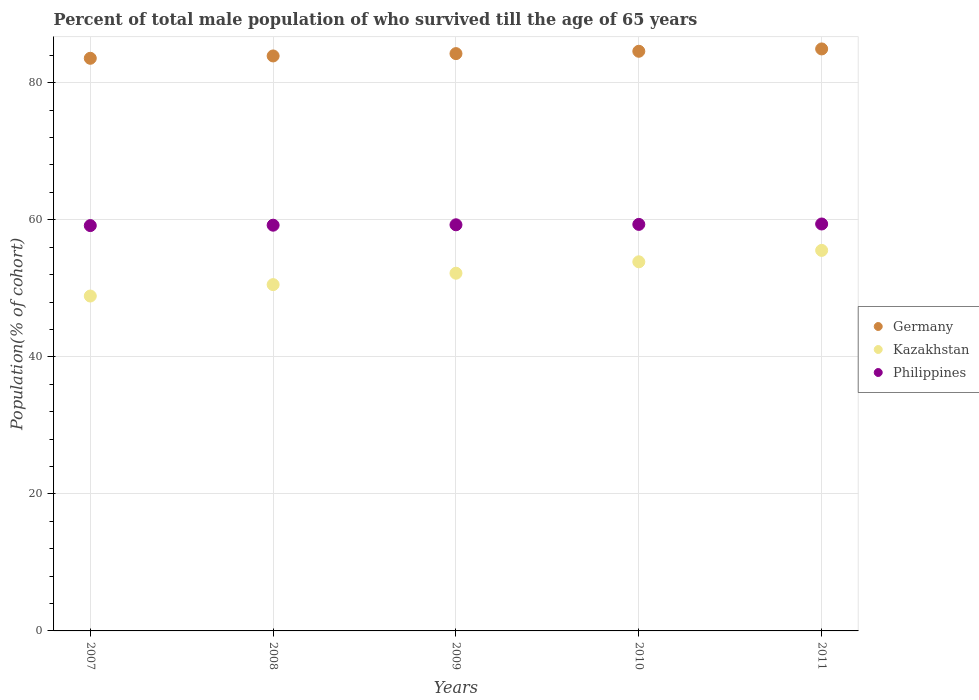What is the percentage of total male population who survived till the age of 65 years in Germany in 2010?
Keep it short and to the point. 84.59. Across all years, what is the maximum percentage of total male population who survived till the age of 65 years in Kazakhstan?
Keep it short and to the point. 55.53. Across all years, what is the minimum percentage of total male population who survived till the age of 65 years in Kazakhstan?
Provide a succinct answer. 48.87. In which year was the percentage of total male population who survived till the age of 65 years in Germany maximum?
Make the answer very short. 2011. In which year was the percentage of total male population who survived till the age of 65 years in Philippines minimum?
Make the answer very short. 2007. What is the total percentage of total male population who survived till the age of 65 years in Kazakhstan in the graph?
Your answer should be compact. 261.01. What is the difference between the percentage of total male population who survived till the age of 65 years in Germany in 2010 and that in 2011?
Ensure brevity in your answer.  -0.34. What is the difference between the percentage of total male population who survived till the age of 65 years in Kazakhstan in 2007 and the percentage of total male population who survived till the age of 65 years in Germany in 2010?
Your answer should be very brief. -35.72. What is the average percentage of total male population who survived till the age of 65 years in Germany per year?
Offer a very short reply. 84.25. In the year 2008, what is the difference between the percentage of total male population who survived till the age of 65 years in Kazakhstan and percentage of total male population who survived till the age of 65 years in Germany?
Provide a succinct answer. -33.37. What is the ratio of the percentage of total male population who survived till the age of 65 years in Germany in 2007 to that in 2008?
Your response must be concise. 1. Is the percentage of total male population who survived till the age of 65 years in Germany in 2008 less than that in 2010?
Your response must be concise. Yes. Is the difference between the percentage of total male population who survived till the age of 65 years in Kazakhstan in 2008 and 2011 greater than the difference between the percentage of total male population who survived till the age of 65 years in Germany in 2008 and 2011?
Provide a succinct answer. No. What is the difference between the highest and the second highest percentage of total male population who survived till the age of 65 years in Kazakhstan?
Offer a terse response. 1.66. What is the difference between the highest and the lowest percentage of total male population who survived till the age of 65 years in Kazakhstan?
Make the answer very short. 6.66. In how many years, is the percentage of total male population who survived till the age of 65 years in Germany greater than the average percentage of total male population who survived till the age of 65 years in Germany taken over all years?
Offer a terse response. 3. Is it the case that in every year, the sum of the percentage of total male population who survived till the age of 65 years in Kazakhstan and percentage of total male population who survived till the age of 65 years in Philippines  is greater than the percentage of total male population who survived till the age of 65 years in Germany?
Keep it short and to the point. Yes. Does the percentage of total male population who survived till the age of 65 years in Kazakhstan monotonically increase over the years?
Offer a very short reply. Yes. Is the percentage of total male population who survived till the age of 65 years in Philippines strictly greater than the percentage of total male population who survived till the age of 65 years in Kazakhstan over the years?
Keep it short and to the point. Yes. Is the percentage of total male population who survived till the age of 65 years in Philippines strictly less than the percentage of total male population who survived till the age of 65 years in Germany over the years?
Your response must be concise. Yes. How many dotlines are there?
Offer a very short reply. 3. How many years are there in the graph?
Offer a terse response. 5. Are the values on the major ticks of Y-axis written in scientific E-notation?
Provide a succinct answer. No. Does the graph contain any zero values?
Make the answer very short. No. Does the graph contain grids?
Provide a succinct answer. Yes. How are the legend labels stacked?
Your answer should be compact. Vertical. What is the title of the graph?
Provide a succinct answer. Percent of total male population of who survived till the age of 65 years. What is the label or title of the X-axis?
Make the answer very short. Years. What is the label or title of the Y-axis?
Your answer should be compact. Population(% of cohort). What is the Population(% of cohort) of Germany in 2007?
Ensure brevity in your answer.  83.57. What is the Population(% of cohort) in Kazakhstan in 2007?
Your answer should be very brief. 48.87. What is the Population(% of cohort) of Philippines in 2007?
Ensure brevity in your answer.  59.15. What is the Population(% of cohort) of Germany in 2008?
Your answer should be very brief. 83.91. What is the Population(% of cohort) in Kazakhstan in 2008?
Ensure brevity in your answer.  50.54. What is the Population(% of cohort) of Philippines in 2008?
Your answer should be compact. 59.21. What is the Population(% of cohort) in Germany in 2009?
Keep it short and to the point. 84.25. What is the Population(% of cohort) of Kazakhstan in 2009?
Your answer should be compact. 52.2. What is the Population(% of cohort) of Philippines in 2009?
Ensure brevity in your answer.  59.27. What is the Population(% of cohort) in Germany in 2010?
Offer a very short reply. 84.59. What is the Population(% of cohort) of Kazakhstan in 2010?
Your answer should be compact. 53.87. What is the Population(% of cohort) of Philippines in 2010?
Make the answer very short. 59.33. What is the Population(% of cohort) of Germany in 2011?
Provide a succinct answer. 84.93. What is the Population(% of cohort) in Kazakhstan in 2011?
Provide a short and direct response. 55.53. What is the Population(% of cohort) of Philippines in 2011?
Ensure brevity in your answer.  59.39. Across all years, what is the maximum Population(% of cohort) of Germany?
Your response must be concise. 84.93. Across all years, what is the maximum Population(% of cohort) in Kazakhstan?
Make the answer very short. 55.53. Across all years, what is the maximum Population(% of cohort) in Philippines?
Make the answer very short. 59.39. Across all years, what is the minimum Population(% of cohort) in Germany?
Your response must be concise. 83.57. Across all years, what is the minimum Population(% of cohort) of Kazakhstan?
Ensure brevity in your answer.  48.87. Across all years, what is the minimum Population(% of cohort) in Philippines?
Provide a short and direct response. 59.15. What is the total Population(% of cohort) of Germany in the graph?
Give a very brief answer. 421.25. What is the total Population(% of cohort) in Kazakhstan in the graph?
Give a very brief answer. 261.01. What is the total Population(% of cohort) of Philippines in the graph?
Provide a succinct answer. 296.35. What is the difference between the Population(% of cohort) in Germany in 2007 and that in 2008?
Your answer should be very brief. -0.34. What is the difference between the Population(% of cohort) in Kazakhstan in 2007 and that in 2008?
Provide a succinct answer. -1.66. What is the difference between the Population(% of cohort) of Philippines in 2007 and that in 2008?
Your answer should be very brief. -0.06. What is the difference between the Population(% of cohort) of Germany in 2007 and that in 2009?
Keep it short and to the point. -0.68. What is the difference between the Population(% of cohort) in Kazakhstan in 2007 and that in 2009?
Your answer should be very brief. -3.33. What is the difference between the Population(% of cohort) in Philippines in 2007 and that in 2009?
Your answer should be very brief. -0.12. What is the difference between the Population(% of cohort) of Germany in 2007 and that in 2010?
Your answer should be very brief. -1.02. What is the difference between the Population(% of cohort) in Kazakhstan in 2007 and that in 2010?
Your answer should be compact. -4.99. What is the difference between the Population(% of cohort) in Philippines in 2007 and that in 2010?
Provide a succinct answer. -0.17. What is the difference between the Population(% of cohort) of Germany in 2007 and that in 2011?
Your answer should be very brief. -1.37. What is the difference between the Population(% of cohort) of Kazakhstan in 2007 and that in 2011?
Ensure brevity in your answer.  -6.66. What is the difference between the Population(% of cohort) of Philippines in 2007 and that in 2011?
Provide a succinct answer. -0.23. What is the difference between the Population(% of cohort) of Germany in 2008 and that in 2009?
Provide a succinct answer. -0.34. What is the difference between the Population(% of cohort) of Kazakhstan in 2008 and that in 2009?
Ensure brevity in your answer.  -1.66. What is the difference between the Population(% of cohort) in Philippines in 2008 and that in 2009?
Ensure brevity in your answer.  -0.06. What is the difference between the Population(% of cohort) in Germany in 2008 and that in 2010?
Keep it short and to the point. -0.68. What is the difference between the Population(% of cohort) of Kazakhstan in 2008 and that in 2010?
Provide a succinct answer. -3.33. What is the difference between the Population(% of cohort) in Philippines in 2008 and that in 2010?
Provide a succinct answer. -0.12. What is the difference between the Population(% of cohort) of Germany in 2008 and that in 2011?
Offer a very short reply. -1.02. What is the difference between the Population(% of cohort) of Kazakhstan in 2008 and that in 2011?
Your answer should be very brief. -4.99. What is the difference between the Population(% of cohort) in Philippines in 2008 and that in 2011?
Make the answer very short. -0.17. What is the difference between the Population(% of cohort) in Germany in 2009 and that in 2010?
Make the answer very short. -0.34. What is the difference between the Population(% of cohort) in Kazakhstan in 2009 and that in 2010?
Offer a very short reply. -1.67. What is the difference between the Population(% of cohort) in Philippines in 2009 and that in 2010?
Offer a terse response. -0.06. What is the difference between the Population(% of cohort) of Germany in 2009 and that in 2011?
Provide a succinct answer. -0.68. What is the difference between the Population(% of cohort) of Kazakhstan in 2009 and that in 2011?
Make the answer very short. -3.33. What is the difference between the Population(% of cohort) of Philippines in 2009 and that in 2011?
Offer a very short reply. -0.12. What is the difference between the Population(% of cohort) of Germany in 2010 and that in 2011?
Your answer should be very brief. -0.34. What is the difference between the Population(% of cohort) in Kazakhstan in 2010 and that in 2011?
Your answer should be very brief. -1.66. What is the difference between the Population(% of cohort) of Philippines in 2010 and that in 2011?
Your answer should be compact. -0.06. What is the difference between the Population(% of cohort) of Germany in 2007 and the Population(% of cohort) of Kazakhstan in 2008?
Your answer should be compact. 33.03. What is the difference between the Population(% of cohort) in Germany in 2007 and the Population(% of cohort) in Philippines in 2008?
Give a very brief answer. 24.36. What is the difference between the Population(% of cohort) of Kazakhstan in 2007 and the Population(% of cohort) of Philippines in 2008?
Offer a very short reply. -10.34. What is the difference between the Population(% of cohort) of Germany in 2007 and the Population(% of cohort) of Kazakhstan in 2009?
Your answer should be compact. 31.37. What is the difference between the Population(% of cohort) in Germany in 2007 and the Population(% of cohort) in Philippines in 2009?
Offer a terse response. 24.3. What is the difference between the Population(% of cohort) in Kazakhstan in 2007 and the Population(% of cohort) in Philippines in 2009?
Offer a very short reply. -10.4. What is the difference between the Population(% of cohort) in Germany in 2007 and the Population(% of cohort) in Kazakhstan in 2010?
Offer a very short reply. 29.7. What is the difference between the Population(% of cohort) in Germany in 2007 and the Population(% of cohort) in Philippines in 2010?
Ensure brevity in your answer.  24.24. What is the difference between the Population(% of cohort) of Kazakhstan in 2007 and the Population(% of cohort) of Philippines in 2010?
Your answer should be compact. -10.45. What is the difference between the Population(% of cohort) in Germany in 2007 and the Population(% of cohort) in Kazakhstan in 2011?
Ensure brevity in your answer.  28.04. What is the difference between the Population(% of cohort) in Germany in 2007 and the Population(% of cohort) in Philippines in 2011?
Ensure brevity in your answer.  24.18. What is the difference between the Population(% of cohort) of Kazakhstan in 2007 and the Population(% of cohort) of Philippines in 2011?
Offer a terse response. -10.51. What is the difference between the Population(% of cohort) in Germany in 2008 and the Population(% of cohort) in Kazakhstan in 2009?
Make the answer very short. 31.71. What is the difference between the Population(% of cohort) of Germany in 2008 and the Population(% of cohort) of Philippines in 2009?
Your answer should be very brief. 24.64. What is the difference between the Population(% of cohort) of Kazakhstan in 2008 and the Population(% of cohort) of Philippines in 2009?
Give a very brief answer. -8.73. What is the difference between the Population(% of cohort) of Germany in 2008 and the Population(% of cohort) of Kazakhstan in 2010?
Offer a terse response. 30.04. What is the difference between the Population(% of cohort) in Germany in 2008 and the Population(% of cohort) in Philippines in 2010?
Your answer should be compact. 24.58. What is the difference between the Population(% of cohort) in Kazakhstan in 2008 and the Population(% of cohort) in Philippines in 2010?
Offer a terse response. -8.79. What is the difference between the Population(% of cohort) in Germany in 2008 and the Population(% of cohort) in Kazakhstan in 2011?
Offer a very short reply. 28.38. What is the difference between the Population(% of cohort) of Germany in 2008 and the Population(% of cohort) of Philippines in 2011?
Your response must be concise. 24.52. What is the difference between the Population(% of cohort) in Kazakhstan in 2008 and the Population(% of cohort) in Philippines in 2011?
Your answer should be very brief. -8.85. What is the difference between the Population(% of cohort) of Germany in 2009 and the Population(% of cohort) of Kazakhstan in 2010?
Ensure brevity in your answer.  30.38. What is the difference between the Population(% of cohort) of Germany in 2009 and the Population(% of cohort) of Philippines in 2010?
Make the answer very short. 24.92. What is the difference between the Population(% of cohort) in Kazakhstan in 2009 and the Population(% of cohort) in Philippines in 2010?
Your answer should be very brief. -7.12. What is the difference between the Population(% of cohort) in Germany in 2009 and the Population(% of cohort) in Kazakhstan in 2011?
Provide a short and direct response. 28.72. What is the difference between the Population(% of cohort) in Germany in 2009 and the Population(% of cohort) in Philippines in 2011?
Offer a very short reply. 24.87. What is the difference between the Population(% of cohort) of Kazakhstan in 2009 and the Population(% of cohort) of Philippines in 2011?
Provide a short and direct response. -7.18. What is the difference between the Population(% of cohort) of Germany in 2010 and the Population(% of cohort) of Kazakhstan in 2011?
Give a very brief answer. 29.06. What is the difference between the Population(% of cohort) of Germany in 2010 and the Population(% of cohort) of Philippines in 2011?
Your response must be concise. 25.21. What is the difference between the Population(% of cohort) in Kazakhstan in 2010 and the Population(% of cohort) in Philippines in 2011?
Make the answer very short. -5.52. What is the average Population(% of cohort) in Germany per year?
Your response must be concise. 84.25. What is the average Population(% of cohort) of Kazakhstan per year?
Make the answer very short. 52.2. What is the average Population(% of cohort) of Philippines per year?
Make the answer very short. 59.27. In the year 2007, what is the difference between the Population(% of cohort) of Germany and Population(% of cohort) of Kazakhstan?
Give a very brief answer. 34.7. In the year 2007, what is the difference between the Population(% of cohort) in Germany and Population(% of cohort) in Philippines?
Your response must be concise. 24.41. In the year 2007, what is the difference between the Population(% of cohort) in Kazakhstan and Population(% of cohort) in Philippines?
Give a very brief answer. -10.28. In the year 2008, what is the difference between the Population(% of cohort) in Germany and Population(% of cohort) in Kazakhstan?
Your response must be concise. 33.37. In the year 2008, what is the difference between the Population(% of cohort) of Germany and Population(% of cohort) of Philippines?
Ensure brevity in your answer.  24.7. In the year 2008, what is the difference between the Population(% of cohort) in Kazakhstan and Population(% of cohort) in Philippines?
Your answer should be very brief. -8.67. In the year 2009, what is the difference between the Population(% of cohort) of Germany and Population(% of cohort) of Kazakhstan?
Your response must be concise. 32.05. In the year 2009, what is the difference between the Population(% of cohort) in Germany and Population(% of cohort) in Philippines?
Provide a succinct answer. 24.98. In the year 2009, what is the difference between the Population(% of cohort) of Kazakhstan and Population(% of cohort) of Philippines?
Your answer should be compact. -7.07. In the year 2010, what is the difference between the Population(% of cohort) of Germany and Population(% of cohort) of Kazakhstan?
Your answer should be compact. 30.72. In the year 2010, what is the difference between the Population(% of cohort) of Germany and Population(% of cohort) of Philippines?
Offer a terse response. 25.26. In the year 2010, what is the difference between the Population(% of cohort) in Kazakhstan and Population(% of cohort) in Philippines?
Make the answer very short. -5.46. In the year 2011, what is the difference between the Population(% of cohort) of Germany and Population(% of cohort) of Kazakhstan?
Provide a short and direct response. 29.4. In the year 2011, what is the difference between the Population(% of cohort) in Germany and Population(% of cohort) in Philippines?
Provide a short and direct response. 25.55. In the year 2011, what is the difference between the Population(% of cohort) of Kazakhstan and Population(% of cohort) of Philippines?
Offer a terse response. -3.85. What is the ratio of the Population(% of cohort) of Germany in 2007 to that in 2008?
Make the answer very short. 1. What is the ratio of the Population(% of cohort) of Kazakhstan in 2007 to that in 2008?
Give a very brief answer. 0.97. What is the ratio of the Population(% of cohort) of Kazakhstan in 2007 to that in 2009?
Your answer should be very brief. 0.94. What is the ratio of the Population(% of cohort) of Germany in 2007 to that in 2010?
Your response must be concise. 0.99. What is the ratio of the Population(% of cohort) in Kazakhstan in 2007 to that in 2010?
Your response must be concise. 0.91. What is the ratio of the Population(% of cohort) in Philippines in 2007 to that in 2010?
Your answer should be very brief. 1. What is the ratio of the Population(% of cohort) in Germany in 2007 to that in 2011?
Keep it short and to the point. 0.98. What is the ratio of the Population(% of cohort) in Kazakhstan in 2007 to that in 2011?
Offer a very short reply. 0.88. What is the ratio of the Population(% of cohort) in Kazakhstan in 2008 to that in 2009?
Your answer should be very brief. 0.97. What is the ratio of the Population(% of cohort) in Philippines in 2008 to that in 2009?
Offer a terse response. 1. What is the ratio of the Population(% of cohort) of Germany in 2008 to that in 2010?
Make the answer very short. 0.99. What is the ratio of the Population(% of cohort) of Kazakhstan in 2008 to that in 2010?
Offer a very short reply. 0.94. What is the ratio of the Population(% of cohort) in Germany in 2008 to that in 2011?
Ensure brevity in your answer.  0.99. What is the ratio of the Population(% of cohort) of Kazakhstan in 2008 to that in 2011?
Offer a terse response. 0.91. What is the ratio of the Population(% of cohort) of Philippines in 2008 to that in 2011?
Offer a terse response. 1. What is the ratio of the Population(% of cohort) in Kazakhstan in 2009 to that in 2010?
Provide a succinct answer. 0.97. What is the ratio of the Population(% of cohort) in Philippines in 2009 to that in 2010?
Provide a short and direct response. 1. What is the ratio of the Population(% of cohort) in Germany in 2009 to that in 2011?
Your answer should be compact. 0.99. What is the ratio of the Population(% of cohort) of Kazakhstan in 2009 to that in 2011?
Keep it short and to the point. 0.94. What is the ratio of the Population(% of cohort) of Philippines in 2009 to that in 2011?
Offer a terse response. 1. What is the ratio of the Population(% of cohort) of Germany in 2010 to that in 2011?
Your answer should be compact. 1. What is the ratio of the Population(% of cohort) of Kazakhstan in 2010 to that in 2011?
Ensure brevity in your answer.  0.97. What is the difference between the highest and the second highest Population(% of cohort) in Germany?
Your answer should be compact. 0.34. What is the difference between the highest and the second highest Population(% of cohort) of Kazakhstan?
Make the answer very short. 1.66. What is the difference between the highest and the second highest Population(% of cohort) in Philippines?
Offer a terse response. 0.06. What is the difference between the highest and the lowest Population(% of cohort) of Germany?
Your answer should be very brief. 1.37. What is the difference between the highest and the lowest Population(% of cohort) of Kazakhstan?
Keep it short and to the point. 6.66. What is the difference between the highest and the lowest Population(% of cohort) of Philippines?
Offer a very short reply. 0.23. 